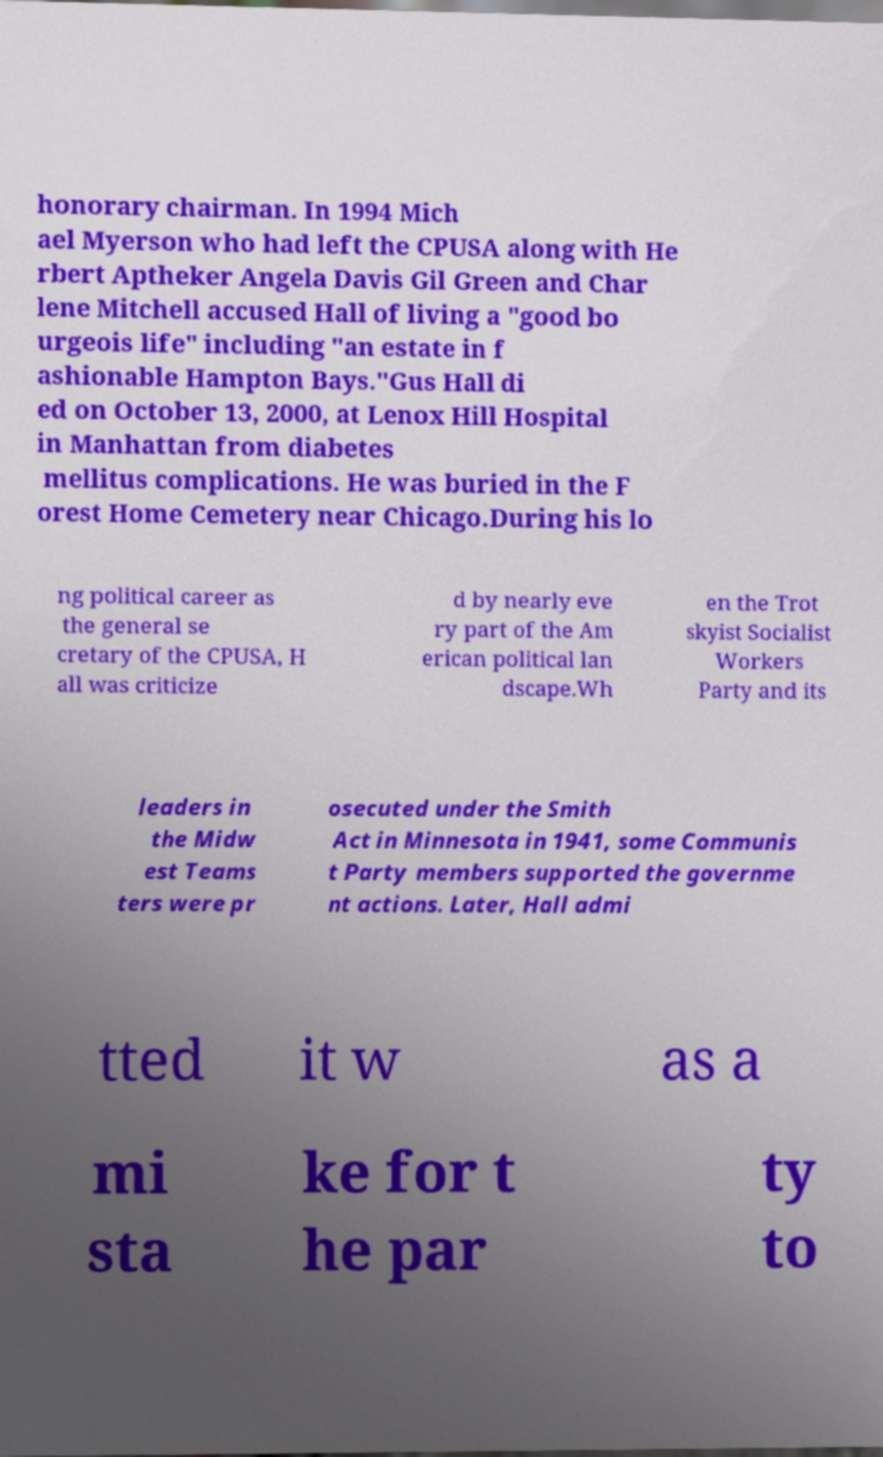Please identify and transcribe the text found in this image. honorary chairman. In 1994 Mich ael Myerson who had left the CPUSA along with He rbert Aptheker Angela Davis Gil Green and Char lene Mitchell accused Hall of living a "good bo urgeois life" including "an estate in f ashionable Hampton Bays."Gus Hall di ed on October 13, 2000, at Lenox Hill Hospital in Manhattan from diabetes mellitus complications. He was buried in the F orest Home Cemetery near Chicago.During his lo ng political career as the general se cretary of the CPUSA, H all was criticize d by nearly eve ry part of the Am erican political lan dscape.Wh en the Trot skyist Socialist Workers Party and its leaders in the Midw est Teams ters were pr osecuted under the Smith Act in Minnesota in 1941, some Communis t Party members supported the governme nt actions. Later, Hall admi tted it w as a mi sta ke for t he par ty to 